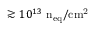Convert formula to latex. <formula><loc_0><loc_0><loc_500><loc_500>\gtrsim 1 0 ^ { 1 3 } n _ { e q } / c m ^ { 2 }</formula> 